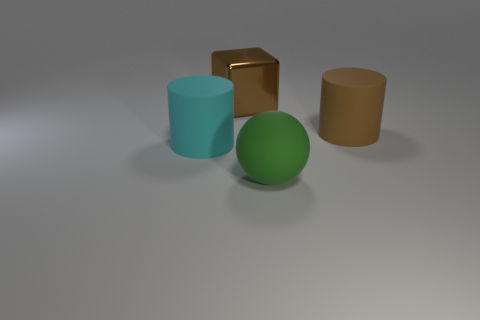There is a cyan matte object that is the same size as the shiny block; what is its shape?
Your answer should be compact. Cylinder. What number of objects are big brown metallic things or cyan cylinders left of the big green matte sphere?
Give a very brief answer. 2. Does the brown object right of the matte sphere have the same material as the brown object to the left of the big brown rubber object?
Ensure brevity in your answer.  No. There is a rubber thing that is the same color as the shiny cube; what is its shape?
Your answer should be very brief. Cylinder. What number of red things are cylinders or shiny objects?
Your answer should be very brief. 0. What is the size of the metal object?
Provide a short and direct response. Large. Is the number of big green rubber spheres that are behind the large cyan object greater than the number of brown metal things?
Offer a terse response. No. How many cyan objects are behind the cyan matte cylinder?
Ensure brevity in your answer.  0. Are there any rubber spheres that have the same size as the green matte thing?
Keep it short and to the point. No. There is another object that is the same shape as the large brown matte object; what color is it?
Your response must be concise. Cyan. 